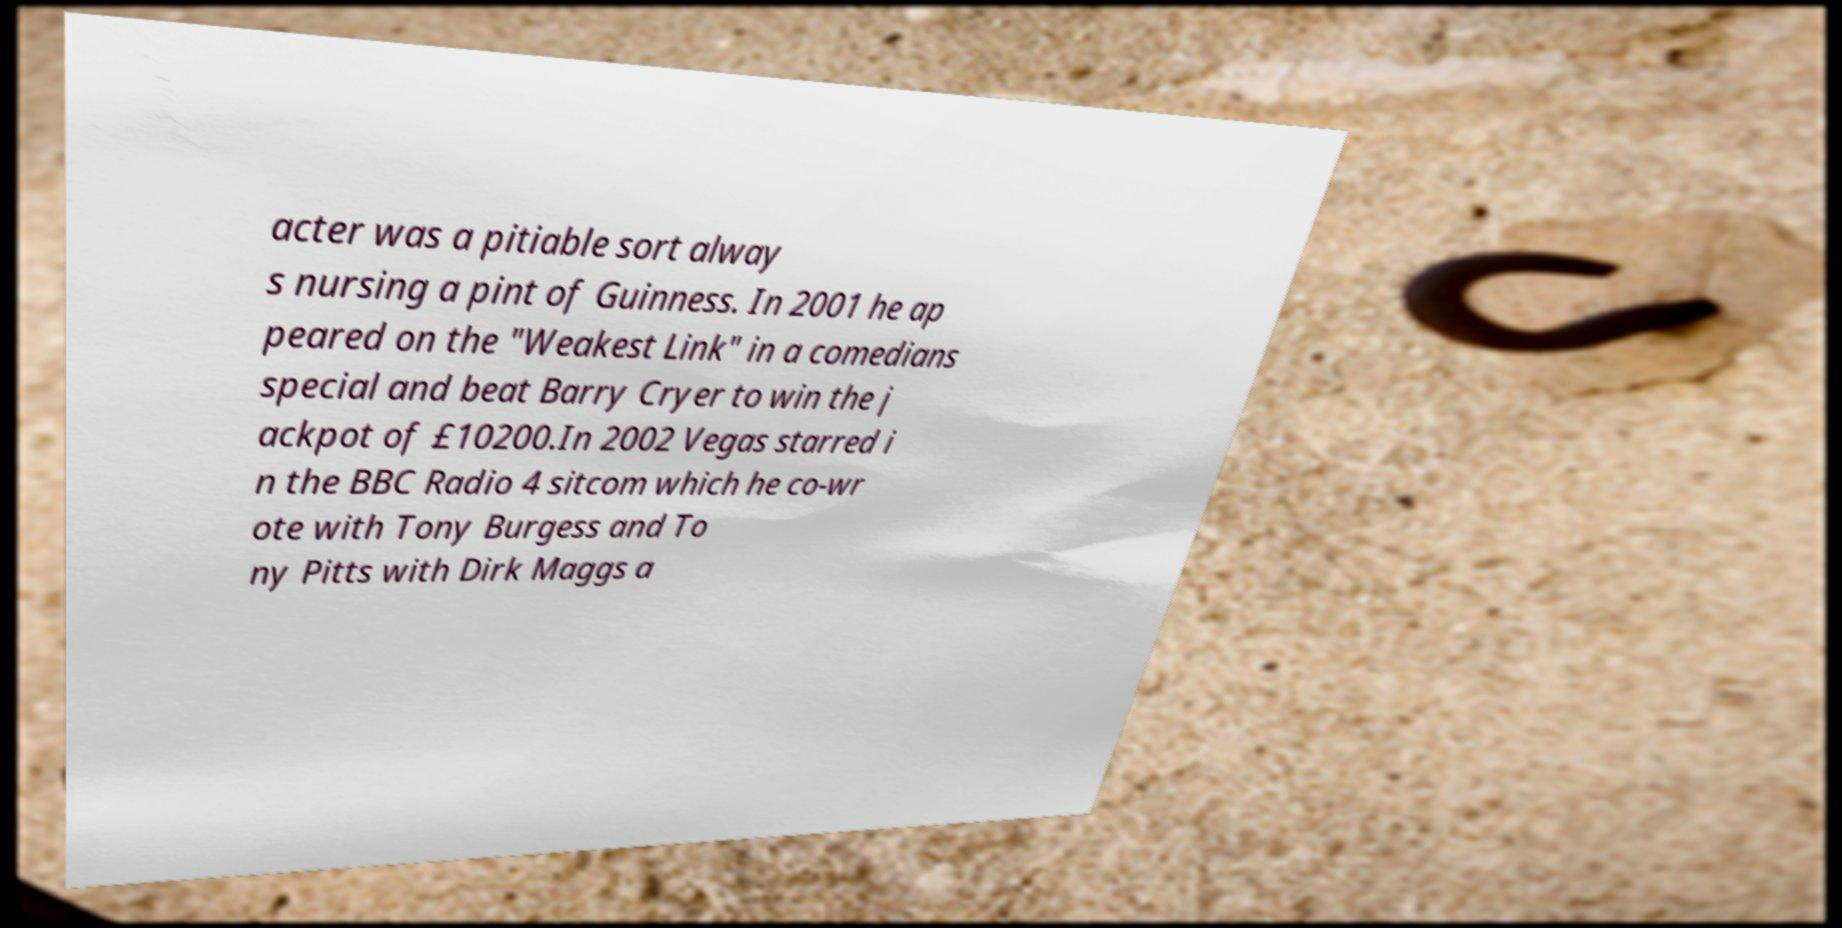Can you accurately transcribe the text from the provided image for me? acter was a pitiable sort alway s nursing a pint of Guinness. In 2001 he ap peared on the "Weakest Link" in a comedians special and beat Barry Cryer to win the j ackpot of £10200.In 2002 Vegas starred i n the BBC Radio 4 sitcom which he co-wr ote with Tony Burgess and To ny Pitts with Dirk Maggs a 